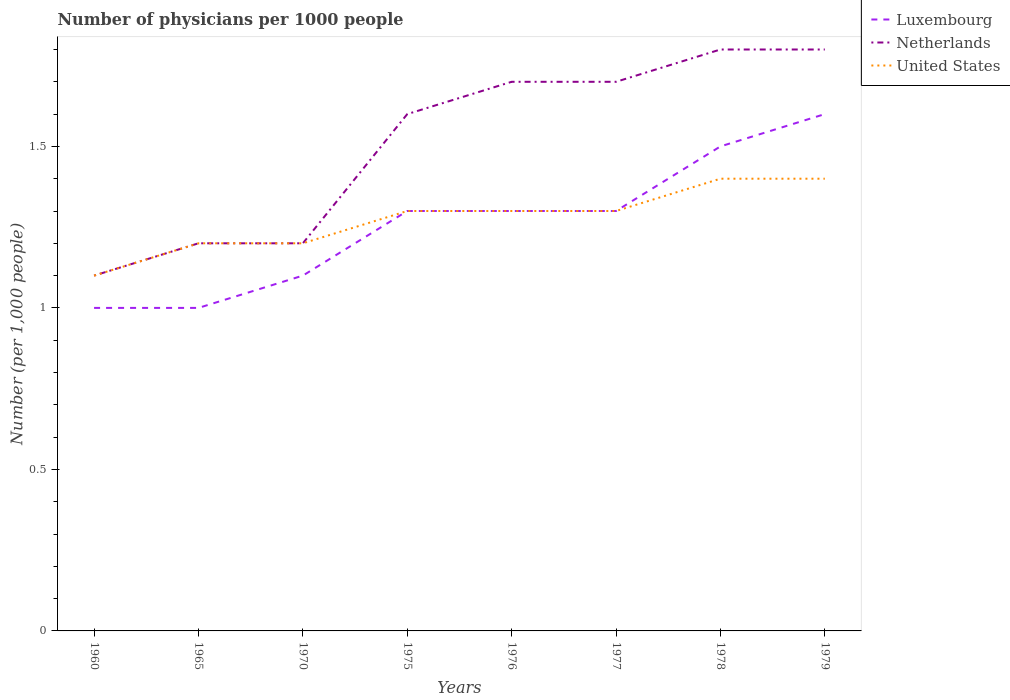How many different coloured lines are there?
Provide a succinct answer. 3. What is the total number of physicians in Netherlands in the graph?
Your answer should be compact. -0.2. What is the difference between the highest and the second highest number of physicians in Luxembourg?
Your answer should be compact. 0.6. What is the difference between the highest and the lowest number of physicians in Luxembourg?
Ensure brevity in your answer.  5. Is the number of physicians in Netherlands strictly greater than the number of physicians in Luxembourg over the years?
Your answer should be very brief. No. Does the graph contain grids?
Your answer should be compact. No. How many legend labels are there?
Make the answer very short. 3. How are the legend labels stacked?
Make the answer very short. Vertical. What is the title of the graph?
Your answer should be very brief. Number of physicians per 1000 people. Does "Angola" appear as one of the legend labels in the graph?
Your answer should be very brief. No. What is the label or title of the Y-axis?
Give a very brief answer. Number (per 1,0 people). What is the Number (per 1,000 people) in Luxembourg in 1960?
Give a very brief answer. 1. What is the Number (per 1,000 people) in Netherlands in 1960?
Provide a succinct answer. 1.1. What is the Number (per 1,000 people) of Netherlands in 1970?
Your answer should be very brief. 1.2. What is the Number (per 1,000 people) of Luxembourg in 1975?
Offer a terse response. 1.3. What is the Number (per 1,000 people) in Luxembourg in 1976?
Your answer should be compact. 1.3. What is the Number (per 1,000 people) of Netherlands in 1976?
Make the answer very short. 1.7. What is the Number (per 1,000 people) of Netherlands in 1977?
Provide a short and direct response. 1.7. What is the Number (per 1,000 people) of United States in 1978?
Ensure brevity in your answer.  1.4. What is the Number (per 1,000 people) in Luxembourg in 1979?
Provide a succinct answer. 1.6. Across all years, what is the maximum Number (per 1,000 people) in Netherlands?
Give a very brief answer. 1.8. Across all years, what is the minimum Number (per 1,000 people) in Luxembourg?
Your response must be concise. 1. Across all years, what is the minimum Number (per 1,000 people) in Netherlands?
Your response must be concise. 1.1. What is the total Number (per 1,000 people) in Luxembourg in the graph?
Provide a short and direct response. 10.1. What is the difference between the Number (per 1,000 people) in Luxembourg in 1960 and that in 1970?
Offer a very short reply. -0.1. What is the difference between the Number (per 1,000 people) in Luxembourg in 1960 and that in 1975?
Make the answer very short. -0.3. What is the difference between the Number (per 1,000 people) in Netherlands in 1960 and that in 1975?
Offer a very short reply. -0.5. What is the difference between the Number (per 1,000 people) of United States in 1960 and that in 1975?
Your response must be concise. -0.2. What is the difference between the Number (per 1,000 people) of Luxembourg in 1960 and that in 1976?
Keep it short and to the point. -0.3. What is the difference between the Number (per 1,000 people) of United States in 1960 and that in 1976?
Offer a very short reply. -0.2. What is the difference between the Number (per 1,000 people) of Luxembourg in 1960 and that in 1977?
Make the answer very short. -0.3. What is the difference between the Number (per 1,000 people) in Netherlands in 1960 and that in 1977?
Give a very brief answer. -0.6. What is the difference between the Number (per 1,000 people) in United States in 1960 and that in 1977?
Make the answer very short. -0.2. What is the difference between the Number (per 1,000 people) of Netherlands in 1960 and that in 1978?
Your answer should be very brief. -0.7. What is the difference between the Number (per 1,000 people) in United States in 1960 and that in 1978?
Make the answer very short. -0.3. What is the difference between the Number (per 1,000 people) of Luxembourg in 1960 and that in 1979?
Your response must be concise. -0.6. What is the difference between the Number (per 1,000 people) in Luxembourg in 1965 and that in 1970?
Your answer should be compact. -0.1. What is the difference between the Number (per 1,000 people) of Netherlands in 1965 and that in 1970?
Your answer should be compact. 0. What is the difference between the Number (per 1,000 people) of Luxembourg in 1965 and that in 1975?
Make the answer very short. -0.3. What is the difference between the Number (per 1,000 people) of Luxembourg in 1965 and that in 1976?
Give a very brief answer. -0.3. What is the difference between the Number (per 1,000 people) of Netherlands in 1965 and that in 1976?
Offer a terse response. -0.5. What is the difference between the Number (per 1,000 people) of Luxembourg in 1965 and that in 1977?
Offer a very short reply. -0.3. What is the difference between the Number (per 1,000 people) in Netherlands in 1965 and that in 1978?
Offer a very short reply. -0.6. What is the difference between the Number (per 1,000 people) in Netherlands in 1965 and that in 1979?
Offer a very short reply. -0.6. What is the difference between the Number (per 1,000 people) of Luxembourg in 1970 and that in 1975?
Your response must be concise. -0.2. What is the difference between the Number (per 1,000 people) in United States in 1970 and that in 1976?
Make the answer very short. -0.1. What is the difference between the Number (per 1,000 people) in Luxembourg in 1970 and that in 1977?
Your answer should be very brief. -0.2. What is the difference between the Number (per 1,000 people) of United States in 1970 and that in 1977?
Your answer should be very brief. -0.1. What is the difference between the Number (per 1,000 people) of Luxembourg in 1970 and that in 1978?
Your answer should be very brief. -0.4. What is the difference between the Number (per 1,000 people) in Netherlands in 1970 and that in 1979?
Your answer should be very brief. -0.6. What is the difference between the Number (per 1,000 people) of United States in 1970 and that in 1979?
Give a very brief answer. -0.2. What is the difference between the Number (per 1,000 people) in Luxembourg in 1975 and that in 1976?
Your response must be concise. 0. What is the difference between the Number (per 1,000 people) of Netherlands in 1975 and that in 1976?
Offer a terse response. -0.1. What is the difference between the Number (per 1,000 people) in Luxembourg in 1975 and that in 1977?
Provide a succinct answer. 0. What is the difference between the Number (per 1,000 people) in Netherlands in 1975 and that in 1977?
Your answer should be very brief. -0.1. What is the difference between the Number (per 1,000 people) of United States in 1975 and that in 1977?
Provide a short and direct response. 0. What is the difference between the Number (per 1,000 people) in Luxembourg in 1975 and that in 1978?
Ensure brevity in your answer.  -0.2. What is the difference between the Number (per 1,000 people) of United States in 1975 and that in 1978?
Offer a terse response. -0.1. What is the difference between the Number (per 1,000 people) of United States in 1975 and that in 1979?
Provide a short and direct response. -0.1. What is the difference between the Number (per 1,000 people) of Luxembourg in 1976 and that in 1977?
Provide a succinct answer. 0. What is the difference between the Number (per 1,000 people) in Luxembourg in 1976 and that in 1978?
Your answer should be compact. -0.2. What is the difference between the Number (per 1,000 people) in Netherlands in 1976 and that in 1978?
Offer a terse response. -0.1. What is the difference between the Number (per 1,000 people) of United States in 1976 and that in 1978?
Give a very brief answer. -0.1. What is the difference between the Number (per 1,000 people) in Netherlands in 1976 and that in 1979?
Make the answer very short. -0.1. What is the difference between the Number (per 1,000 people) of Luxembourg in 1977 and that in 1978?
Make the answer very short. -0.2. What is the difference between the Number (per 1,000 people) in Netherlands in 1977 and that in 1978?
Offer a terse response. -0.1. What is the difference between the Number (per 1,000 people) of Luxembourg in 1977 and that in 1979?
Ensure brevity in your answer.  -0.3. What is the difference between the Number (per 1,000 people) of Netherlands in 1977 and that in 1979?
Provide a succinct answer. -0.1. What is the difference between the Number (per 1,000 people) of United States in 1978 and that in 1979?
Provide a short and direct response. 0. What is the difference between the Number (per 1,000 people) in Luxembourg in 1960 and the Number (per 1,000 people) in Netherlands in 1965?
Offer a terse response. -0.2. What is the difference between the Number (per 1,000 people) of Luxembourg in 1960 and the Number (per 1,000 people) of United States in 1965?
Your answer should be very brief. -0.2. What is the difference between the Number (per 1,000 people) of Netherlands in 1960 and the Number (per 1,000 people) of United States in 1965?
Provide a succinct answer. -0.1. What is the difference between the Number (per 1,000 people) of Luxembourg in 1960 and the Number (per 1,000 people) of Netherlands in 1970?
Make the answer very short. -0.2. What is the difference between the Number (per 1,000 people) in Luxembourg in 1960 and the Number (per 1,000 people) in United States in 1970?
Provide a short and direct response. -0.2. What is the difference between the Number (per 1,000 people) in Netherlands in 1960 and the Number (per 1,000 people) in United States in 1970?
Ensure brevity in your answer.  -0.1. What is the difference between the Number (per 1,000 people) of Luxembourg in 1960 and the Number (per 1,000 people) of Netherlands in 1975?
Offer a very short reply. -0.6. What is the difference between the Number (per 1,000 people) in Luxembourg in 1960 and the Number (per 1,000 people) in United States in 1975?
Your answer should be very brief. -0.3. What is the difference between the Number (per 1,000 people) of Netherlands in 1960 and the Number (per 1,000 people) of United States in 1975?
Provide a short and direct response. -0.2. What is the difference between the Number (per 1,000 people) in Luxembourg in 1960 and the Number (per 1,000 people) in Netherlands in 1976?
Give a very brief answer. -0.7. What is the difference between the Number (per 1,000 people) in Luxembourg in 1960 and the Number (per 1,000 people) in United States in 1976?
Provide a short and direct response. -0.3. What is the difference between the Number (per 1,000 people) of Luxembourg in 1960 and the Number (per 1,000 people) of Netherlands in 1979?
Your answer should be compact. -0.8. What is the difference between the Number (per 1,000 people) of Luxembourg in 1965 and the Number (per 1,000 people) of Netherlands in 1970?
Provide a succinct answer. -0.2. What is the difference between the Number (per 1,000 people) in Luxembourg in 1965 and the Number (per 1,000 people) in United States in 1970?
Your response must be concise. -0.2. What is the difference between the Number (per 1,000 people) of Luxembourg in 1965 and the Number (per 1,000 people) of United States in 1976?
Ensure brevity in your answer.  -0.3. What is the difference between the Number (per 1,000 people) of Luxembourg in 1965 and the Number (per 1,000 people) of Netherlands in 1977?
Your answer should be very brief. -0.7. What is the difference between the Number (per 1,000 people) of Luxembourg in 1965 and the Number (per 1,000 people) of United States in 1978?
Keep it short and to the point. -0.4. What is the difference between the Number (per 1,000 people) of Netherlands in 1965 and the Number (per 1,000 people) of United States in 1978?
Provide a short and direct response. -0.2. What is the difference between the Number (per 1,000 people) in Luxembourg in 1965 and the Number (per 1,000 people) in United States in 1979?
Offer a very short reply. -0.4. What is the difference between the Number (per 1,000 people) of Luxembourg in 1970 and the Number (per 1,000 people) of Netherlands in 1975?
Make the answer very short. -0.5. What is the difference between the Number (per 1,000 people) in Luxembourg in 1970 and the Number (per 1,000 people) in United States in 1976?
Provide a short and direct response. -0.2. What is the difference between the Number (per 1,000 people) in Netherlands in 1970 and the Number (per 1,000 people) in United States in 1976?
Ensure brevity in your answer.  -0.1. What is the difference between the Number (per 1,000 people) in Luxembourg in 1970 and the Number (per 1,000 people) in Netherlands in 1977?
Your answer should be compact. -0.6. What is the difference between the Number (per 1,000 people) in Luxembourg in 1975 and the Number (per 1,000 people) in Netherlands in 1976?
Provide a succinct answer. -0.4. What is the difference between the Number (per 1,000 people) in Luxembourg in 1975 and the Number (per 1,000 people) in United States in 1976?
Your answer should be compact. 0. What is the difference between the Number (per 1,000 people) of Netherlands in 1975 and the Number (per 1,000 people) of United States in 1976?
Your response must be concise. 0.3. What is the difference between the Number (per 1,000 people) in Luxembourg in 1975 and the Number (per 1,000 people) in United States in 1977?
Your answer should be compact. 0. What is the difference between the Number (per 1,000 people) of Netherlands in 1975 and the Number (per 1,000 people) of United States in 1977?
Offer a very short reply. 0.3. What is the difference between the Number (per 1,000 people) in Luxembourg in 1975 and the Number (per 1,000 people) in Netherlands in 1978?
Provide a short and direct response. -0.5. What is the difference between the Number (per 1,000 people) in Luxembourg in 1975 and the Number (per 1,000 people) in United States in 1978?
Ensure brevity in your answer.  -0.1. What is the difference between the Number (per 1,000 people) of Netherlands in 1975 and the Number (per 1,000 people) of United States in 1978?
Give a very brief answer. 0.2. What is the difference between the Number (per 1,000 people) of Luxembourg in 1975 and the Number (per 1,000 people) of Netherlands in 1979?
Your answer should be compact. -0.5. What is the difference between the Number (per 1,000 people) of Netherlands in 1975 and the Number (per 1,000 people) of United States in 1979?
Make the answer very short. 0.2. What is the difference between the Number (per 1,000 people) of Luxembourg in 1976 and the Number (per 1,000 people) of Netherlands in 1977?
Ensure brevity in your answer.  -0.4. What is the difference between the Number (per 1,000 people) in Netherlands in 1976 and the Number (per 1,000 people) in United States in 1977?
Ensure brevity in your answer.  0.4. What is the difference between the Number (per 1,000 people) of Luxembourg in 1976 and the Number (per 1,000 people) of Netherlands in 1978?
Keep it short and to the point. -0.5. What is the difference between the Number (per 1,000 people) of Luxembourg in 1976 and the Number (per 1,000 people) of United States in 1978?
Keep it short and to the point. -0.1. What is the difference between the Number (per 1,000 people) of Luxembourg in 1976 and the Number (per 1,000 people) of Netherlands in 1979?
Give a very brief answer. -0.5. What is the difference between the Number (per 1,000 people) of Luxembourg in 1976 and the Number (per 1,000 people) of United States in 1979?
Make the answer very short. -0.1. What is the difference between the Number (per 1,000 people) in Luxembourg in 1977 and the Number (per 1,000 people) in Netherlands in 1978?
Offer a very short reply. -0.5. What is the difference between the Number (per 1,000 people) of Netherlands in 1977 and the Number (per 1,000 people) of United States in 1978?
Give a very brief answer. 0.3. What is the difference between the Number (per 1,000 people) of Netherlands in 1977 and the Number (per 1,000 people) of United States in 1979?
Offer a terse response. 0.3. What is the difference between the Number (per 1,000 people) in Luxembourg in 1978 and the Number (per 1,000 people) in United States in 1979?
Provide a short and direct response. 0.1. What is the difference between the Number (per 1,000 people) in Netherlands in 1978 and the Number (per 1,000 people) in United States in 1979?
Offer a very short reply. 0.4. What is the average Number (per 1,000 people) of Luxembourg per year?
Your answer should be very brief. 1.26. What is the average Number (per 1,000 people) in Netherlands per year?
Keep it short and to the point. 1.51. What is the average Number (per 1,000 people) in United States per year?
Provide a short and direct response. 1.27. In the year 1960, what is the difference between the Number (per 1,000 people) in Netherlands and Number (per 1,000 people) in United States?
Your response must be concise. 0. In the year 1965, what is the difference between the Number (per 1,000 people) of Luxembourg and Number (per 1,000 people) of Netherlands?
Offer a terse response. -0.2. In the year 1970, what is the difference between the Number (per 1,000 people) in Luxembourg and Number (per 1,000 people) in United States?
Give a very brief answer. -0.1. In the year 1975, what is the difference between the Number (per 1,000 people) of Luxembourg and Number (per 1,000 people) of United States?
Provide a short and direct response. 0. In the year 1976, what is the difference between the Number (per 1,000 people) of Luxembourg and Number (per 1,000 people) of United States?
Offer a terse response. 0. In the year 1977, what is the difference between the Number (per 1,000 people) of Luxembourg and Number (per 1,000 people) of Netherlands?
Ensure brevity in your answer.  -0.4. In the year 1977, what is the difference between the Number (per 1,000 people) in Netherlands and Number (per 1,000 people) in United States?
Your answer should be compact. 0.4. In the year 1978, what is the difference between the Number (per 1,000 people) of Luxembourg and Number (per 1,000 people) of Netherlands?
Ensure brevity in your answer.  -0.3. In the year 1978, what is the difference between the Number (per 1,000 people) of Netherlands and Number (per 1,000 people) of United States?
Keep it short and to the point. 0.4. In the year 1979, what is the difference between the Number (per 1,000 people) of Luxembourg and Number (per 1,000 people) of Netherlands?
Provide a succinct answer. -0.2. What is the ratio of the Number (per 1,000 people) of Luxembourg in 1960 to that in 1965?
Give a very brief answer. 1. What is the ratio of the Number (per 1,000 people) in Luxembourg in 1960 to that in 1975?
Make the answer very short. 0.77. What is the ratio of the Number (per 1,000 people) in Netherlands in 1960 to that in 1975?
Ensure brevity in your answer.  0.69. What is the ratio of the Number (per 1,000 people) in United States in 1960 to that in 1975?
Your response must be concise. 0.85. What is the ratio of the Number (per 1,000 people) in Luxembourg in 1960 to that in 1976?
Make the answer very short. 0.77. What is the ratio of the Number (per 1,000 people) in Netherlands in 1960 to that in 1976?
Provide a succinct answer. 0.65. What is the ratio of the Number (per 1,000 people) of United States in 1960 to that in 1976?
Provide a short and direct response. 0.85. What is the ratio of the Number (per 1,000 people) in Luxembourg in 1960 to that in 1977?
Make the answer very short. 0.77. What is the ratio of the Number (per 1,000 people) of Netherlands in 1960 to that in 1977?
Offer a very short reply. 0.65. What is the ratio of the Number (per 1,000 people) of United States in 1960 to that in 1977?
Make the answer very short. 0.85. What is the ratio of the Number (per 1,000 people) in Luxembourg in 1960 to that in 1978?
Provide a succinct answer. 0.67. What is the ratio of the Number (per 1,000 people) in Netherlands in 1960 to that in 1978?
Your answer should be compact. 0.61. What is the ratio of the Number (per 1,000 people) in United States in 1960 to that in 1978?
Keep it short and to the point. 0.79. What is the ratio of the Number (per 1,000 people) of Netherlands in 1960 to that in 1979?
Give a very brief answer. 0.61. What is the ratio of the Number (per 1,000 people) in United States in 1960 to that in 1979?
Your response must be concise. 0.79. What is the ratio of the Number (per 1,000 people) in Luxembourg in 1965 to that in 1970?
Your response must be concise. 0.91. What is the ratio of the Number (per 1,000 people) of Luxembourg in 1965 to that in 1975?
Ensure brevity in your answer.  0.77. What is the ratio of the Number (per 1,000 people) of Netherlands in 1965 to that in 1975?
Your answer should be compact. 0.75. What is the ratio of the Number (per 1,000 people) in Luxembourg in 1965 to that in 1976?
Offer a terse response. 0.77. What is the ratio of the Number (per 1,000 people) of Netherlands in 1965 to that in 1976?
Your response must be concise. 0.71. What is the ratio of the Number (per 1,000 people) of Luxembourg in 1965 to that in 1977?
Keep it short and to the point. 0.77. What is the ratio of the Number (per 1,000 people) of Netherlands in 1965 to that in 1977?
Provide a short and direct response. 0.71. What is the ratio of the Number (per 1,000 people) of Netherlands in 1965 to that in 1978?
Provide a succinct answer. 0.67. What is the ratio of the Number (per 1,000 people) in United States in 1965 to that in 1978?
Your answer should be compact. 0.86. What is the ratio of the Number (per 1,000 people) of Netherlands in 1965 to that in 1979?
Your response must be concise. 0.67. What is the ratio of the Number (per 1,000 people) in Luxembourg in 1970 to that in 1975?
Your response must be concise. 0.85. What is the ratio of the Number (per 1,000 people) of United States in 1970 to that in 1975?
Keep it short and to the point. 0.92. What is the ratio of the Number (per 1,000 people) of Luxembourg in 1970 to that in 1976?
Your response must be concise. 0.85. What is the ratio of the Number (per 1,000 people) in Netherlands in 1970 to that in 1976?
Keep it short and to the point. 0.71. What is the ratio of the Number (per 1,000 people) in Luxembourg in 1970 to that in 1977?
Keep it short and to the point. 0.85. What is the ratio of the Number (per 1,000 people) in Netherlands in 1970 to that in 1977?
Offer a terse response. 0.71. What is the ratio of the Number (per 1,000 people) in United States in 1970 to that in 1977?
Keep it short and to the point. 0.92. What is the ratio of the Number (per 1,000 people) in Luxembourg in 1970 to that in 1978?
Your answer should be very brief. 0.73. What is the ratio of the Number (per 1,000 people) in United States in 1970 to that in 1978?
Offer a terse response. 0.86. What is the ratio of the Number (per 1,000 people) of Luxembourg in 1970 to that in 1979?
Keep it short and to the point. 0.69. What is the ratio of the Number (per 1,000 people) of United States in 1970 to that in 1979?
Ensure brevity in your answer.  0.86. What is the ratio of the Number (per 1,000 people) of Luxembourg in 1975 to that in 1977?
Provide a short and direct response. 1. What is the ratio of the Number (per 1,000 people) in Netherlands in 1975 to that in 1977?
Your response must be concise. 0.94. What is the ratio of the Number (per 1,000 people) in Luxembourg in 1975 to that in 1978?
Offer a terse response. 0.87. What is the ratio of the Number (per 1,000 people) of Netherlands in 1975 to that in 1978?
Provide a short and direct response. 0.89. What is the ratio of the Number (per 1,000 people) in Luxembourg in 1975 to that in 1979?
Offer a terse response. 0.81. What is the ratio of the Number (per 1,000 people) in Netherlands in 1975 to that in 1979?
Your answer should be very brief. 0.89. What is the ratio of the Number (per 1,000 people) of Luxembourg in 1976 to that in 1978?
Offer a terse response. 0.87. What is the ratio of the Number (per 1,000 people) in Luxembourg in 1976 to that in 1979?
Keep it short and to the point. 0.81. What is the ratio of the Number (per 1,000 people) in United States in 1976 to that in 1979?
Give a very brief answer. 0.93. What is the ratio of the Number (per 1,000 people) of Luxembourg in 1977 to that in 1978?
Provide a succinct answer. 0.87. What is the ratio of the Number (per 1,000 people) in Luxembourg in 1977 to that in 1979?
Your answer should be compact. 0.81. What is the ratio of the Number (per 1,000 people) of Luxembourg in 1978 to that in 1979?
Your answer should be compact. 0.94. What is the ratio of the Number (per 1,000 people) of Netherlands in 1978 to that in 1979?
Your response must be concise. 1. What is the ratio of the Number (per 1,000 people) of United States in 1978 to that in 1979?
Offer a terse response. 1. What is the difference between the highest and the second highest Number (per 1,000 people) of Luxembourg?
Your answer should be very brief. 0.1. What is the difference between the highest and the lowest Number (per 1,000 people) in Luxembourg?
Ensure brevity in your answer.  0.6. 